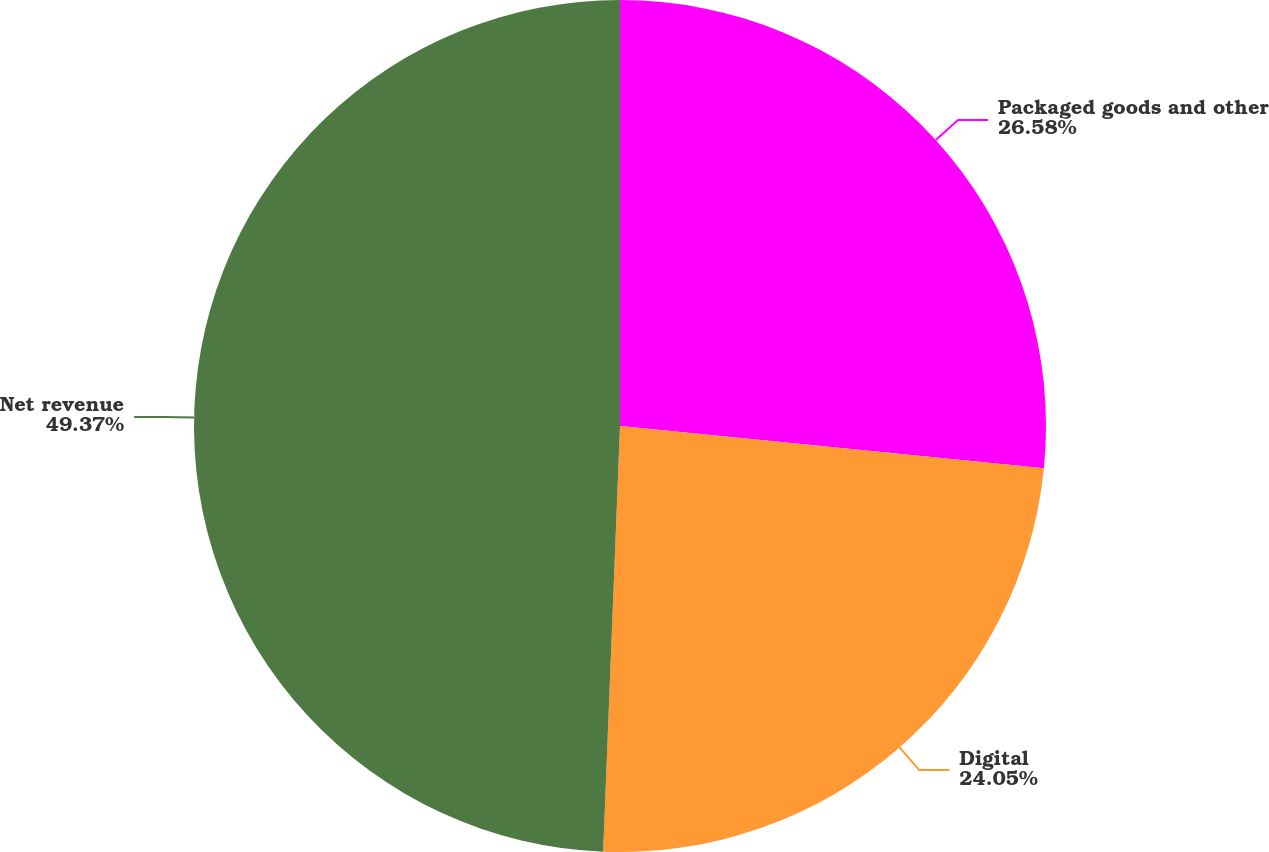Convert chart to OTSL. <chart><loc_0><loc_0><loc_500><loc_500><pie_chart><fcel>Packaged goods and other<fcel>Digital<fcel>Net revenue<nl><fcel>26.58%<fcel>24.05%<fcel>49.37%<nl></chart> 